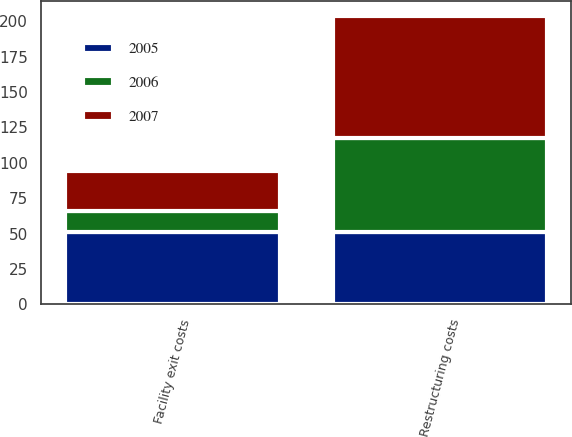Convert chart. <chart><loc_0><loc_0><loc_500><loc_500><stacked_bar_chart><ecel><fcel>Facility exit costs<fcel>Restructuring costs<nl><fcel>2007<fcel>27.7<fcel>86<nl><fcel>2006<fcel>14.9<fcel>66.4<nl><fcel>2005<fcel>51.3<fcel>51.3<nl></chart> 